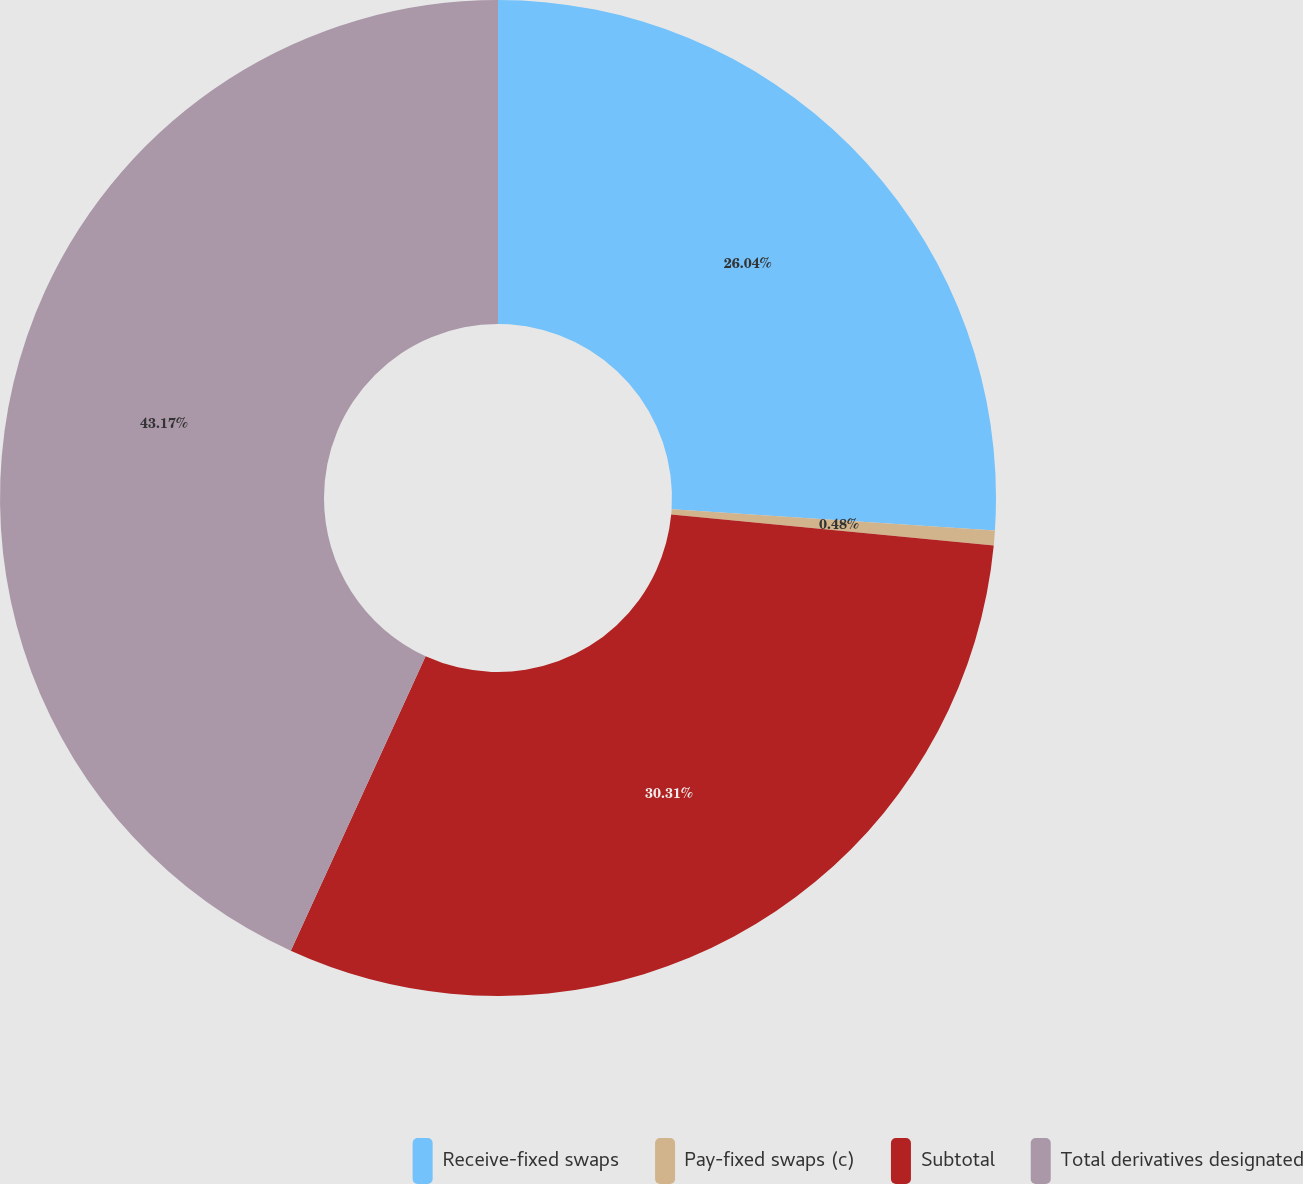Convert chart. <chart><loc_0><loc_0><loc_500><loc_500><pie_chart><fcel>Receive-fixed swaps<fcel>Pay-fixed swaps (c)<fcel>Subtotal<fcel>Total derivatives designated<nl><fcel>26.04%<fcel>0.48%<fcel>30.31%<fcel>43.17%<nl></chart> 